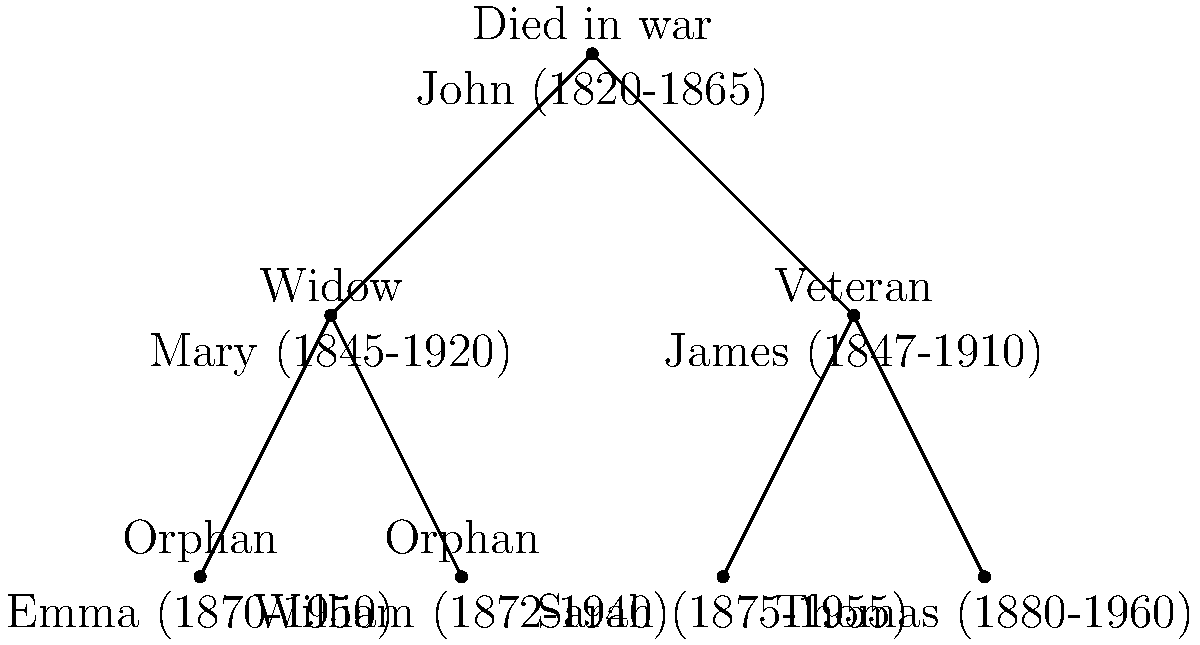Analyze the family tree diagram depicting the impact of the Civil War on the Johnson family. How many of John's grandchildren were directly affected by his death in the war? To answer this question, we need to follow these steps:

1. Identify John in the family tree:
   John (1820-1865) is at the top of the tree, labeled "Died in war".

2. Identify John's children:
   - Mary (1845-1920), labeled "Widow"
   - James (1847-1910), labeled "Veteran"

3. Identify John's grandchildren:
   - Mary's children:
     a. Emma (1870-1950), labeled "Orphan"
     b. William (1872-1940), labeled "Orphan"
   - James's children:
     c. Sarah (1875-1955)
     d. Thomas (1880-1960)

4. Determine which grandchildren were directly affected:
   - Emma and William are labeled as "Orphan", indicating they were directly affected by John's death in the war.
   - Sarah and Thomas do not have any specific labels indicating direct impact.

5. Count the number of affected grandchildren:
   2 grandchildren (Emma and William) were directly affected by John's death in the war.
Answer: 2 